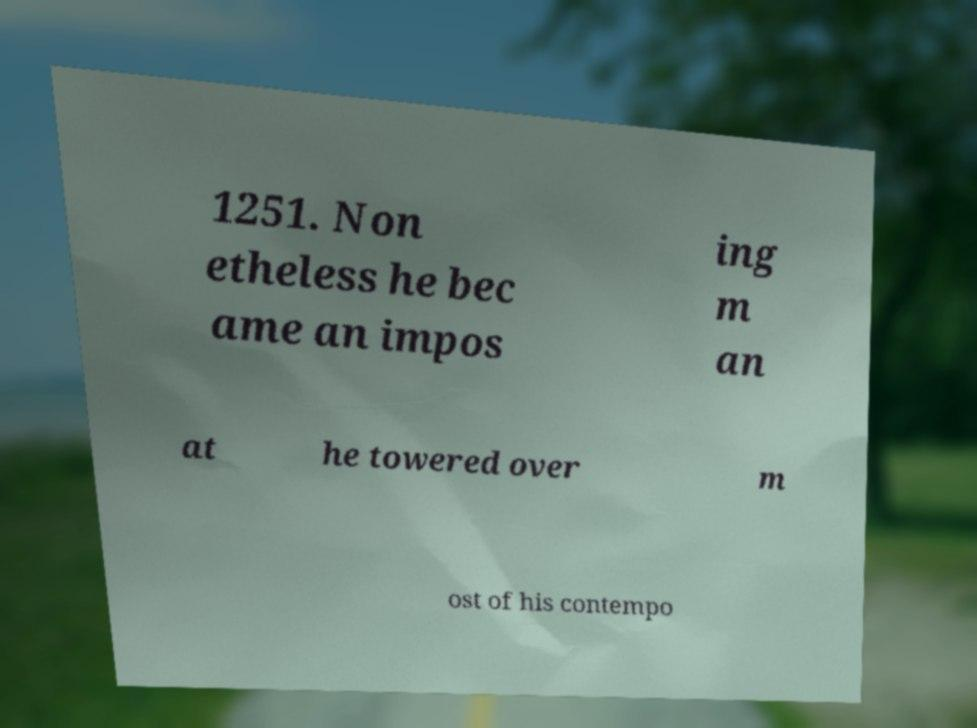What messages or text are displayed in this image? I need them in a readable, typed format. 1251. Non etheless he bec ame an impos ing m an at he towered over m ost of his contempo 